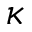Convert formula to latex. <formula><loc_0><loc_0><loc_500><loc_500>\kappa</formula> 